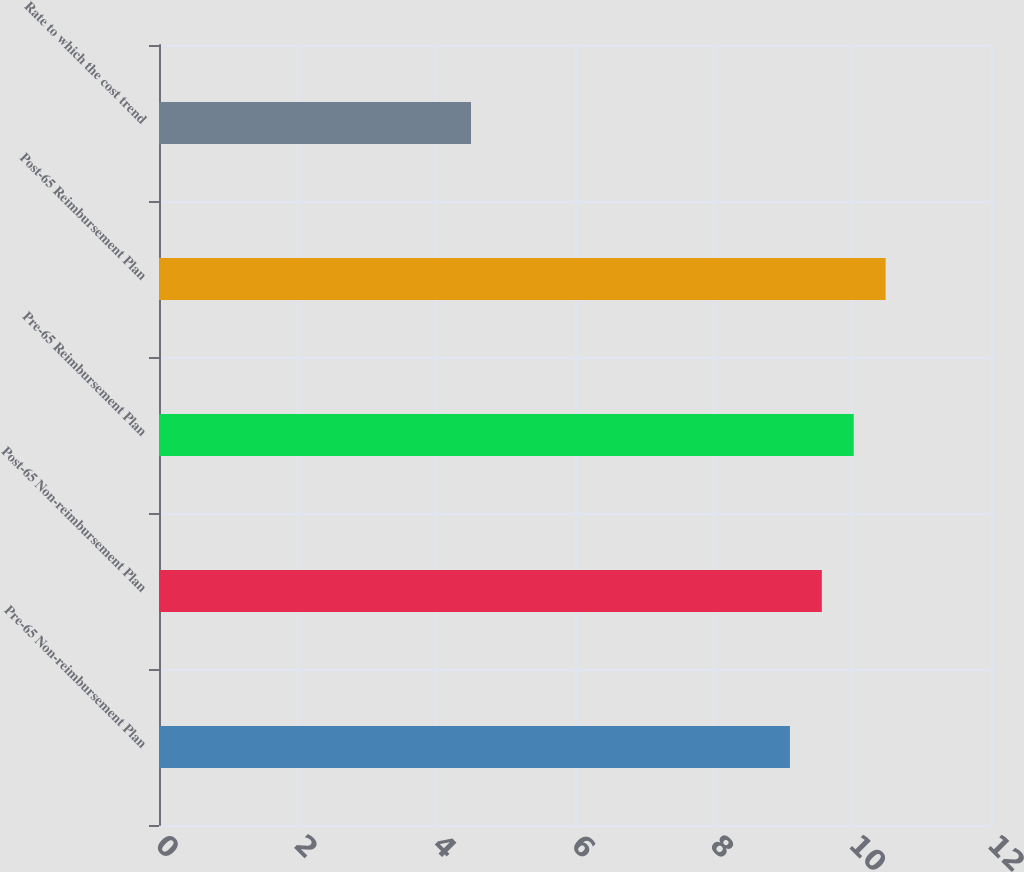<chart> <loc_0><loc_0><loc_500><loc_500><bar_chart><fcel>Pre-65 Non-reimbursement Plan<fcel>Post-65 Non-reimbursement Plan<fcel>Pre-65 Reimbursement Plan<fcel>Post-65 Reimbursement Plan<fcel>Rate to which the cost trend<nl><fcel>9.1<fcel>9.56<fcel>10.02<fcel>10.48<fcel>4.5<nl></chart> 